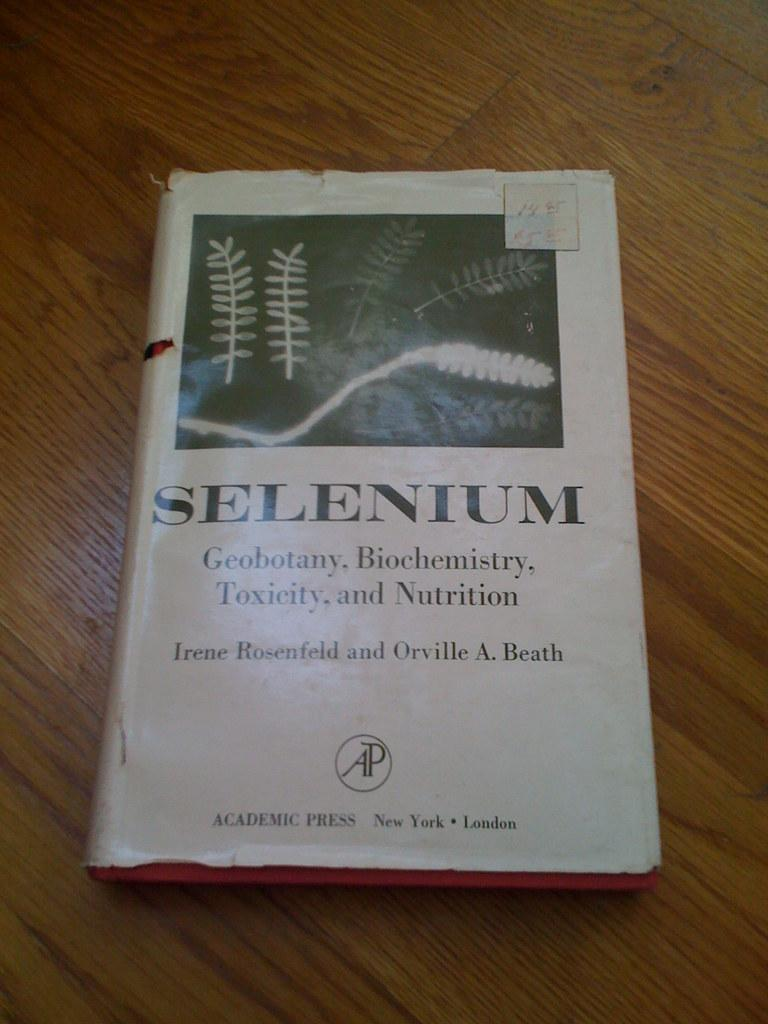<image>
Offer a succinct explanation of the picture presented. An old dust jacket covered book entitled Selenium. 